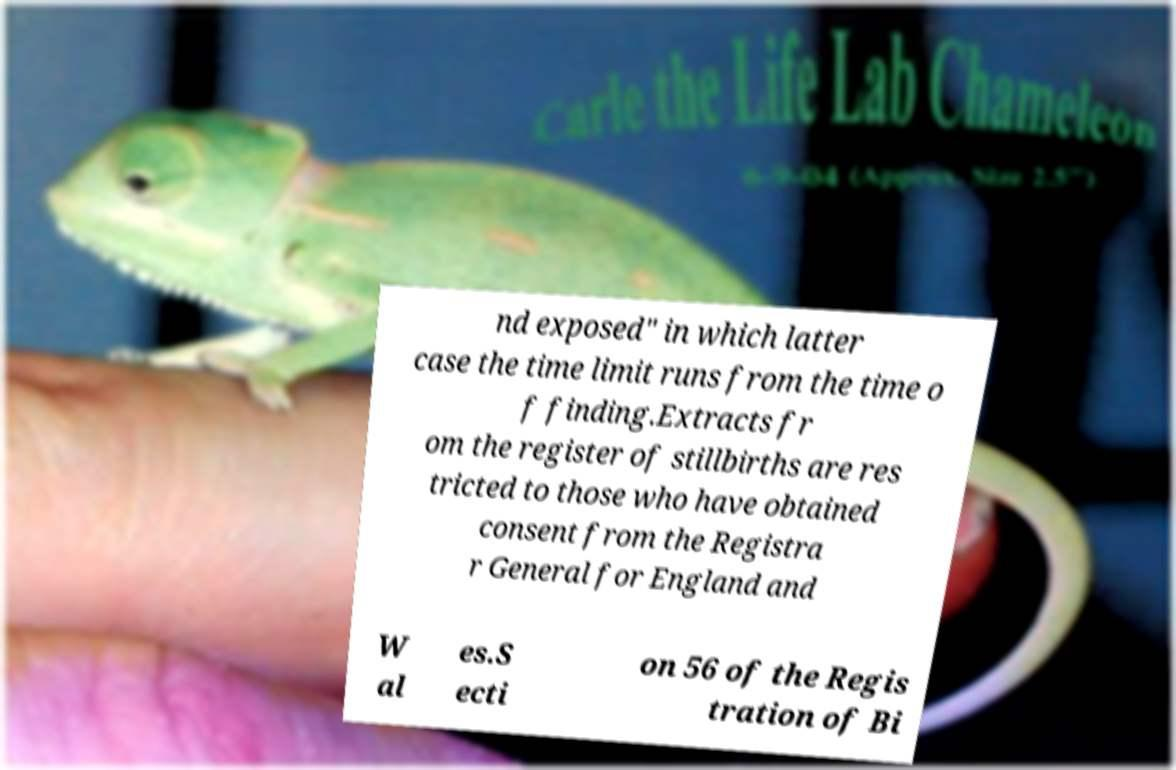Could you assist in decoding the text presented in this image and type it out clearly? nd exposed" in which latter case the time limit runs from the time o f finding.Extracts fr om the register of stillbirths are res tricted to those who have obtained consent from the Registra r General for England and W al es.S ecti on 56 of the Regis tration of Bi 